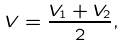<formula> <loc_0><loc_0><loc_500><loc_500>V = \frac { V _ { 1 } + V _ { 2 } } { 2 } ,</formula> 